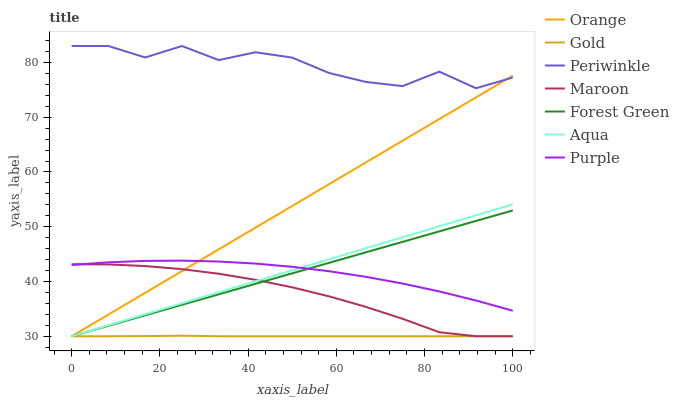Does Purple have the minimum area under the curve?
Answer yes or no. No. Does Purple have the maximum area under the curve?
Answer yes or no. No. Is Purple the smoothest?
Answer yes or no. No. Is Purple the roughest?
Answer yes or no. No. Does Purple have the lowest value?
Answer yes or no. No. Does Purple have the highest value?
Answer yes or no. No. Is Forest Green less than Periwinkle?
Answer yes or no. Yes. Is Periwinkle greater than Maroon?
Answer yes or no. Yes. Does Forest Green intersect Periwinkle?
Answer yes or no. No. 